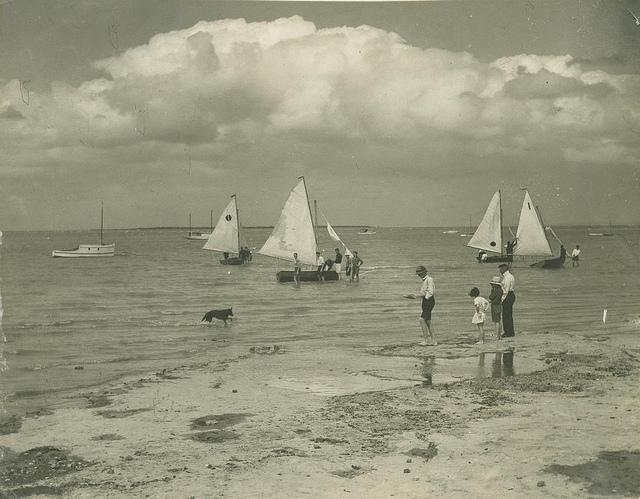What type of vehicles are in the water? Please explain your reasoning. sailboat. This vehicle uses the wind and a piece of canvas as the propulsion to move it through the water. 